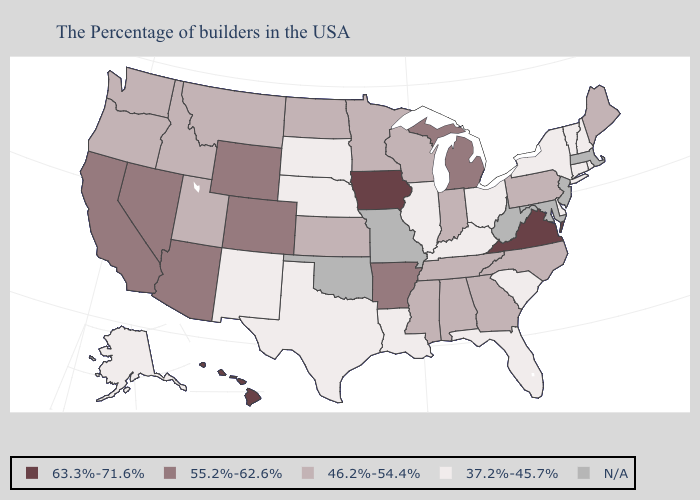What is the value of Louisiana?
Quick response, please. 37.2%-45.7%. Name the states that have a value in the range 63.3%-71.6%?
Concise answer only. Virginia, Iowa, Hawaii. Does Hawaii have the highest value in the West?
Be succinct. Yes. What is the value of Kentucky?
Keep it brief. 37.2%-45.7%. What is the value of Vermont?
Give a very brief answer. 37.2%-45.7%. What is the highest value in states that border West Virginia?
Give a very brief answer. 63.3%-71.6%. Which states hav the highest value in the South?
Give a very brief answer. Virginia. What is the value of Wisconsin?
Keep it brief. 46.2%-54.4%. What is the value of Kansas?
Quick response, please. 46.2%-54.4%. Which states have the highest value in the USA?
Answer briefly. Virginia, Iowa, Hawaii. What is the value of Oregon?
Write a very short answer. 46.2%-54.4%. How many symbols are there in the legend?
Be succinct. 5. Does Ohio have the highest value in the MidWest?
Concise answer only. No. What is the value of Oregon?
Quick response, please. 46.2%-54.4%. Does Virginia have the highest value in the USA?
Give a very brief answer. Yes. 